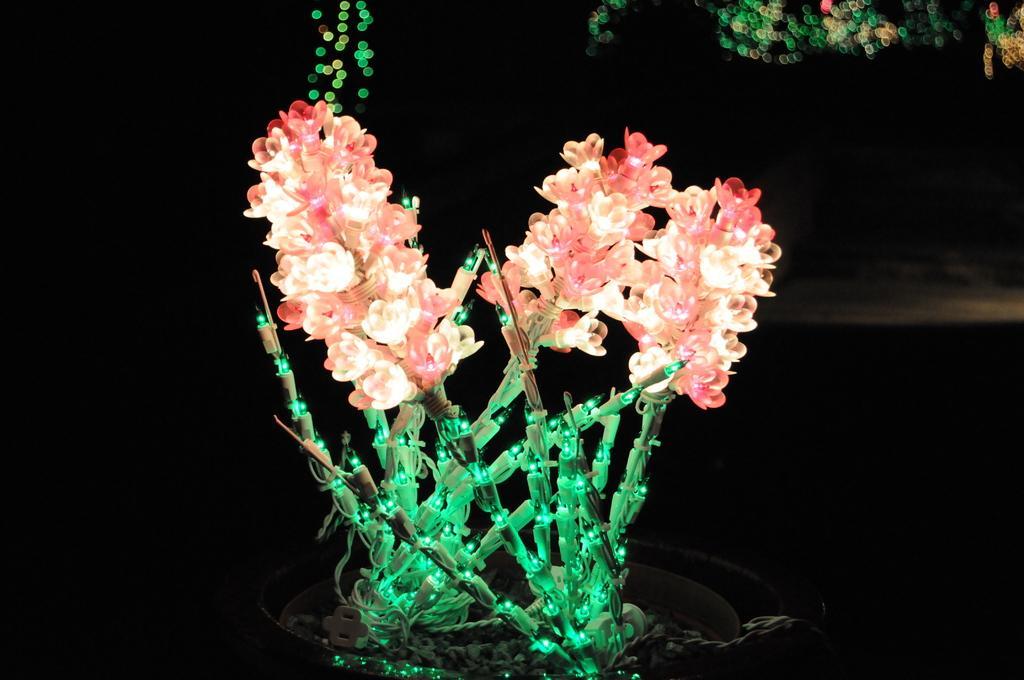In one or two sentences, can you explain what this image depicts? In this picture we can see decorative lights, wires and in the background it is dark. 